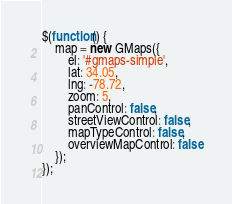<code> <loc_0><loc_0><loc_500><loc_500><_JavaScript_>$(function() {
    map = new GMaps({
        el: '#gmaps-simple',
        lat: 34.05,
        lng: -78.72,
        zoom: 5,
        panControl: false,
        streetViewControl: false,
        mapTypeControl: false,
        overviewMapControl: false
    });
});
</code> 